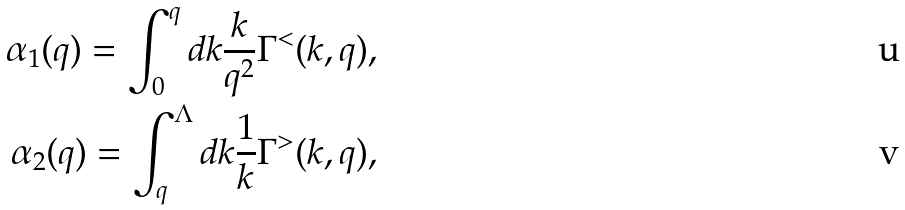Convert formula to latex. <formula><loc_0><loc_0><loc_500><loc_500>\alpha _ { 1 } ( q ) = \int _ { 0 } ^ { q } d k \frac { k } { q ^ { 2 } } \Gamma ^ { < } ( k , q ) , \\ \alpha _ { 2 } ( q ) = \int _ { q } ^ { \Lambda } d k \frac { 1 } { k } \Gamma ^ { > } ( k , q ) ,</formula> 